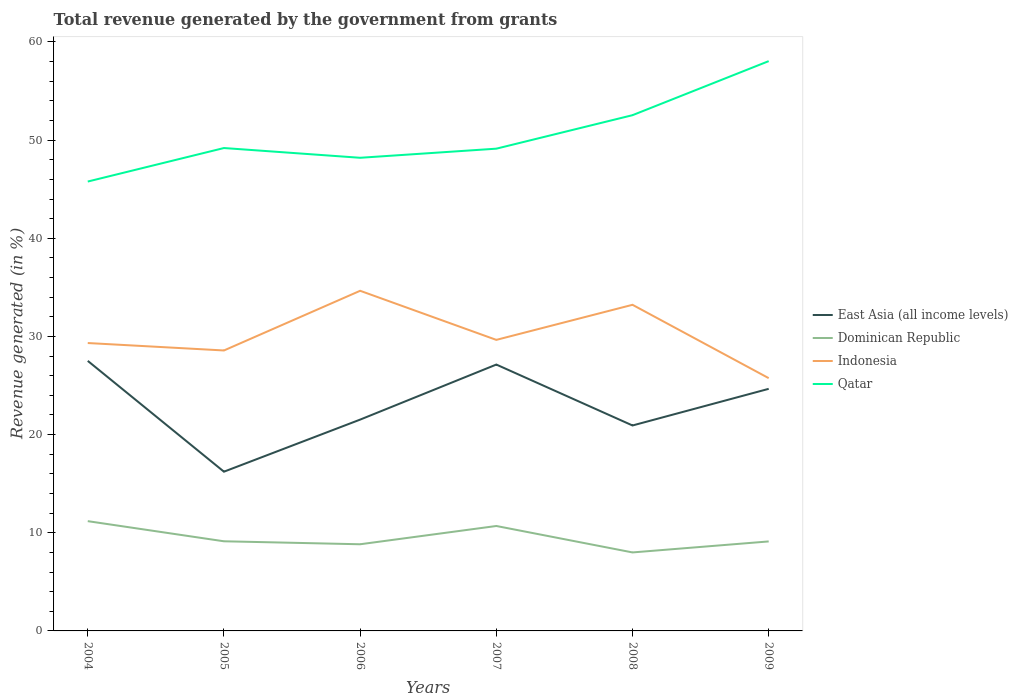How many different coloured lines are there?
Your response must be concise. 4. Does the line corresponding to Dominican Republic intersect with the line corresponding to Indonesia?
Ensure brevity in your answer.  No. Across all years, what is the maximum total revenue generated in Indonesia?
Ensure brevity in your answer.  25.75. What is the total total revenue generated in Dominican Republic in the graph?
Provide a succinct answer. 2.05. What is the difference between the highest and the second highest total revenue generated in Qatar?
Offer a very short reply. 12.27. What is the difference between two consecutive major ticks on the Y-axis?
Ensure brevity in your answer.  10. Are the values on the major ticks of Y-axis written in scientific E-notation?
Provide a succinct answer. No. Does the graph contain grids?
Your answer should be very brief. No. How many legend labels are there?
Give a very brief answer. 4. How are the legend labels stacked?
Make the answer very short. Vertical. What is the title of the graph?
Ensure brevity in your answer.  Total revenue generated by the government from grants. What is the label or title of the Y-axis?
Your answer should be very brief. Revenue generated (in %). What is the Revenue generated (in %) of East Asia (all income levels) in 2004?
Your answer should be compact. 27.51. What is the Revenue generated (in %) in Dominican Republic in 2004?
Your response must be concise. 11.18. What is the Revenue generated (in %) of Indonesia in 2004?
Offer a very short reply. 29.33. What is the Revenue generated (in %) in Qatar in 2004?
Keep it short and to the point. 45.78. What is the Revenue generated (in %) of East Asia (all income levels) in 2005?
Ensure brevity in your answer.  16.22. What is the Revenue generated (in %) in Dominican Republic in 2005?
Keep it short and to the point. 9.13. What is the Revenue generated (in %) in Indonesia in 2005?
Offer a terse response. 28.57. What is the Revenue generated (in %) in Qatar in 2005?
Give a very brief answer. 49.2. What is the Revenue generated (in %) of East Asia (all income levels) in 2006?
Your answer should be compact. 21.53. What is the Revenue generated (in %) of Dominican Republic in 2006?
Your answer should be very brief. 8.83. What is the Revenue generated (in %) of Indonesia in 2006?
Offer a very short reply. 34.65. What is the Revenue generated (in %) in Qatar in 2006?
Give a very brief answer. 48.2. What is the Revenue generated (in %) of East Asia (all income levels) in 2007?
Ensure brevity in your answer.  27.14. What is the Revenue generated (in %) in Dominican Republic in 2007?
Keep it short and to the point. 10.69. What is the Revenue generated (in %) of Indonesia in 2007?
Keep it short and to the point. 29.65. What is the Revenue generated (in %) in Qatar in 2007?
Make the answer very short. 49.13. What is the Revenue generated (in %) of East Asia (all income levels) in 2008?
Give a very brief answer. 20.93. What is the Revenue generated (in %) in Dominican Republic in 2008?
Your answer should be very brief. 8. What is the Revenue generated (in %) of Indonesia in 2008?
Offer a very short reply. 33.23. What is the Revenue generated (in %) in Qatar in 2008?
Your answer should be very brief. 52.54. What is the Revenue generated (in %) in East Asia (all income levels) in 2009?
Offer a terse response. 24.66. What is the Revenue generated (in %) in Dominican Republic in 2009?
Keep it short and to the point. 9.12. What is the Revenue generated (in %) of Indonesia in 2009?
Your answer should be very brief. 25.75. What is the Revenue generated (in %) in Qatar in 2009?
Provide a succinct answer. 58.05. Across all years, what is the maximum Revenue generated (in %) of East Asia (all income levels)?
Your answer should be very brief. 27.51. Across all years, what is the maximum Revenue generated (in %) in Dominican Republic?
Offer a terse response. 11.18. Across all years, what is the maximum Revenue generated (in %) in Indonesia?
Offer a very short reply. 34.65. Across all years, what is the maximum Revenue generated (in %) in Qatar?
Keep it short and to the point. 58.05. Across all years, what is the minimum Revenue generated (in %) in East Asia (all income levels)?
Make the answer very short. 16.22. Across all years, what is the minimum Revenue generated (in %) of Dominican Republic?
Your response must be concise. 8. Across all years, what is the minimum Revenue generated (in %) in Indonesia?
Make the answer very short. 25.75. Across all years, what is the minimum Revenue generated (in %) of Qatar?
Your response must be concise. 45.78. What is the total Revenue generated (in %) in East Asia (all income levels) in the graph?
Make the answer very short. 138. What is the total Revenue generated (in %) of Dominican Republic in the graph?
Ensure brevity in your answer.  56.95. What is the total Revenue generated (in %) of Indonesia in the graph?
Ensure brevity in your answer.  181.19. What is the total Revenue generated (in %) of Qatar in the graph?
Give a very brief answer. 302.91. What is the difference between the Revenue generated (in %) in East Asia (all income levels) in 2004 and that in 2005?
Give a very brief answer. 11.29. What is the difference between the Revenue generated (in %) of Dominican Republic in 2004 and that in 2005?
Make the answer very short. 2.05. What is the difference between the Revenue generated (in %) in Indonesia in 2004 and that in 2005?
Offer a very short reply. 0.76. What is the difference between the Revenue generated (in %) of Qatar in 2004 and that in 2005?
Ensure brevity in your answer.  -3.41. What is the difference between the Revenue generated (in %) of East Asia (all income levels) in 2004 and that in 2006?
Keep it short and to the point. 5.98. What is the difference between the Revenue generated (in %) in Dominican Republic in 2004 and that in 2006?
Make the answer very short. 2.35. What is the difference between the Revenue generated (in %) in Indonesia in 2004 and that in 2006?
Offer a terse response. -5.32. What is the difference between the Revenue generated (in %) in Qatar in 2004 and that in 2006?
Give a very brief answer. -2.42. What is the difference between the Revenue generated (in %) of East Asia (all income levels) in 2004 and that in 2007?
Ensure brevity in your answer.  0.37. What is the difference between the Revenue generated (in %) of Dominican Republic in 2004 and that in 2007?
Your answer should be very brief. 0.49. What is the difference between the Revenue generated (in %) of Indonesia in 2004 and that in 2007?
Your response must be concise. -0.32. What is the difference between the Revenue generated (in %) of Qatar in 2004 and that in 2007?
Your response must be concise. -3.35. What is the difference between the Revenue generated (in %) in East Asia (all income levels) in 2004 and that in 2008?
Your response must be concise. 6.58. What is the difference between the Revenue generated (in %) in Dominican Republic in 2004 and that in 2008?
Offer a terse response. 3.19. What is the difference between the Revenue generated (in %) of Indonesia in 2004 and that in 2008?
Your response must be concise. -3.89. What is the difference between the Revenue generated (in %) in Qatar in 2004 and that in 2008?
Ensure brevity in your answer.  -6.76. What is the difference between the Revenue generated (in %) of East Asia (all income levels) in 2004 and that in 2009?
Provide a short and direct response. 2.85. What is the difference between the Revenue generated (in %) in Dominican Republic in 2004 and that in 2009?
Your answer should be very brief. 2.07. What is the difference between the Revenue generated (in %) of Indonesia in 2004 and that in 2009?
Offer a terse response. 3.58. What is the difference between the Revenue generated (in %) of Qatar in 2004 and that in 2009?
Offer a very short reply. -12.27. What is the difference between the Revenue generated (in %) of East Asia (all income levels) in 2005 and that in 2006?
Provide a succinct answer. -5.31. What is the difference between the Revenue generated (in %) of Dominican Republic in 2005 and that in 2006?
Your answer should be compact. 0.3. What is the difference between the Revenue generated (in %) of Indonesia in 2005 and that in 2006?
Your response must be concise. -6.08. What is the difference between the Revenue generated (in %) in Qatar in 2005 and that in 2006?
Ensure brevity in your answer.  0.99. What is the difference between the Revenue generated (in %) in East Asia (all income levels) in 2005 and that in 2007?
Give a very brief answer. -10.91. What is the difference between the Revenue generated (in %) of Dominican Republic in 2005 and that in 2007?
Keep it short and to the point. -1.56. What is the difference between the Revenue generated (in %) of Indonesia in 2005 and that in 2007?
Provide a short and direct response. -1.08. What is the difference between the Revenue generated (in %) in Qatar in 2005 and that in 2007?
Your answer should be very brief. 0.06. What is the difference between the Revenue generated (in %) in East Asia (all income levels) in 2005 and that in 2008?
Provide a succinct answer. -4.71. What is the difference between the Revenue generated (in %) in Dominican Republic in 2005 and that in 2008?
Ensure brevity in your answer.  1.14. What is the difference between the Revenue generated (in %) of Indonesia in 2005 and that in 2008?
Offer a terse response. -4.65. What is the difference between the Revenue generated (in %) of Qatar in 2005 and that in 2008?
Ensure brevity in your answer.  -3.35. What is the difference between the Revenue generated (in %) of East Asia (all income levels) in 2005 and that in 2009?
Offer a very short reply. -8.44. What is the difference between the Revenue generated (in %) of Dominican Republic in 2005 and that in 2009?
Offer a very short reply. 0.01. What is the difference between the Revenue generated (in %) of Indonesia in 2005 and that in 2009?
Keep it short and to the point. 2.82. What is the difference between the Revenue generated (in %) of Qatar in 2005 and that in 2009?
Give a very brief answer. -8.85. What is the difference between the Revenue generated (in %) in East Asia (all income levels) in 2006 and that in 2007?
Provide a short and direct response. -5.61. What is the difference between the Revenue generated (in %) in Dominican Republic in 2006 and that in 2007?
Give a very brief answer. -1.86. What is the difference between the Revenue generated (in %) of Indonesia in 2006 and that in 2007?
Keep it short and to the point. 5. What is the difference between the Revenue generated (in %) of Qatar in 2006 and that in 2007?
Provide a succinct answer. -0.93. What is the difference between the Revenue generated (in %) of East Asia (all income levels) in 2006 and that in 2008?
Ensure brevity in your answer.  0.6. What is the difference between the Revenue generated (in %) in Dominican Republic in 2006 and that in 2008?
Make the answer very short. 0.83. What is the difference between the Revenue generated (in %) in Indonesia in 2006 and that in 2008?
Your answer should be compact. 1.43. What is the difference between the Revenue generated (in %) of Qatar in 2006 and that in 2008?
Offer a very short reply. -4.34. What is the difference between the Revenue generated (in %) in East Asia (all income levels) in 2006 and that in 2009?
Give a very brief answer. -3.13. What is the difference between the Revenue generated (in %) of Dominican Republic in 2006 and that in 2009?
Your answer should be very brief. -0.29. What is the difference between the Revenue generated (in %) in Indonesia in 2006 and that in 2009?
Offer a very short reply. 8.9. What is the difference between the Revenue generated (in %) in Qatar in 2006 and that in 2009?
Keep it short and to the point. -9.85. What is the difference between the Revenue generated (in %) of East Asia (all income levels) in 2007 and that in 2008?
Keep it short and to the point. 6.21. What is the difference between the Revenue generated (in %) in Dominican Republic in 2007 and that in 2008?
Provide a succinct answer. 2.69. What is the difference between the Revenue generated (in %) of Indonesia in 2007 and that in 2008?
Make the answer very short. -3.57. What is the difference between the Revenue generated (in %) of Qatar in 2007 and that in 2008?
Provide a succinct answer. -3.41. What is the difference between the Revenue generated (in %) in East Asia (all income levels) in 2007 and that in 2009?
Provide a short and direct response. 2.47. What is the difference between the Revenue generated (in %) of Dominican Republic in 2007 and that in 2009?
Offer a very short reply. 1.57. What is the difference between the Revenue generated (in %) of Indonesia in 2007 and that in 2009?
Your answer should be compact. 3.9. What is the difference between the Revenue generated (in %) in Qatar in 2007 and that in 2009?
Make the answer very short. -8.92. What is the difference between the Revenue generated (in %) of East Asia (all income levels) in 2008 and that in 2009?
Your answer should be compact. -3.73. What is the difference between the Revenue generated (in %) in Dominican Republic in 2008 and that in 2009?
Keep it short and to the point. -1.12. What is the difference between the Revenue generated (in %) of Indonesia in 2008 and that in 2009?
Your response must be concise. 7.47. What is the difference between the Revenue generated (in %) in Qatar in 2008 and that in 2009?
Your answer should be compact. -5.51. What is the difference between the Revenue generated (in %) in East Asia (all income levels) in 2004 and the Revenue generated (in %) in Dominican Republic in 2005?
Your answer should be very brief. 18.38. What is the difference between the Revenue generated (in %) of East Asia (all income levels) in 2004 and the Revenue generated (in %) of Indonesia in 2005?
Provide a short and direct response. -1.06. What is the difference between the Revenue generated (in %) in East Asia (all income levels) in 2004 and the Revenue generated (in %) in Qatar in 2005?
Give a very brief answer. -21.68. What is the difference between the Revenue generated (in %) in Dominican Republic in 2004 and the Revenue generated (in %) in Indonesia in 2005?
Keep it short and to the point. -17.39. What is the difference between the Revenue generated (in %) of Dominican Republic in 2004 and the Revenue generated (in %) of Qatar in 2005?
Provide a short and direct response. -38.01. What is the difference between the Revenue generated (in %) in Indonesia in 2004 and the Revenue generated (in %) in Qatar in 2005?
Your answer should be compact. -19.87. What is the difference between the Revenue generated (in %) of East Asia (all income levels) in 2004 and the Revenue generated (in %) of Dominican Republic in 2006?
Keep it short and to the point. 18.68. What is the difference between the Revenue generated (in %) in East Asia (all income levels) in 2004 and the Revenue generated (in %) in Indonesia in 2006?
Make the answer very short. -7.14. What is the difference between the Revenue generated (in %) of East Asia (all income levels) in 2004 and the Revenue generated (in %) of Qatar in 2006?
Make the answer very short. -20.69. What is the difference between the Revenue generated (in %) of Dominican Republic in 2004 and the Revenue generated (in %) of Indonesia in 2006?
Provide a succinct answer. -23.47. What is the difference between the Revenue generated (in %) in Dominican Republic in 2004 and the Revenue generated (in %) in Qatar in 2006?
Offer a very short reply. -37.02. What is the difference between the Revenue generated (in %) of Indonesia in 2004 and the Revenue generated (in %) of Qatar in 2006?
Offer a very short reply. -18.87. What is the difference between the Revenue generated (in %) in East Asia (all income levels) in 2004 and the Revenue generated (in %) in Dominican Republic in 2007?
Provide a short and direct response. 16.82. What is the difference between the Revenue generated (in %) of East Asia (all income levels) in 2004 and the Revenue generated (in %) of Indonesia in 2007?
Keep it short and to the point. -2.14. What is the difference between the Revenue generated (in %) of East Asia (all income levels) in 2004 and the Revenue generated (in %) of Qatar in 2007?
Make the answer very short. -21.62. What is the difference between the Revenue generated (in %) in Dominican Republic in 2004 and the Revenue generated (in %) in Indonesia in 2007?
Provide a short and direct response. -18.47. What is the difference between the Revenue generated (in %) of Dominican Republic in 2004 and the Revenue generated (in %) of Qatar in 2007?
Provide a short and direct response. -37.95. What is the difference between the Revenue generated (in %) in Indonesia in 2004 and the Revenue generated (in %) in Qatar in 2007?
Give a very brief answer. -19.8. What is the difference between the Revenue generated (in %) in East Asia (all income levels) in 2004 and the Revenue generated (in %) in Dominican Republic in 2008?
Provide a succinct answer. 19.52. What is the difference between the Revenue generated (in %) in East Asia (all income levels) in 2004 and the Revenue generated (in %) in Indonesia in 2008?
Keep it short and to the point. -5.71. What is the difference between the Revenue generated (in %) of East Asia (all income levels) in 2004 and the Revenue generated (in %) of Qatar in 2008?
Offer a very short reply. -25.03. What is the difference between the Revenue generated (in %) in Dominican Republic in 2004 and the Revenue generated (in %) in Indonesia in 2008?
Provide a short and direct response. -22.04. What is the difference between the Revenue generated (in %) in Dominican Republic in 2004 and the Revenue generated (in %) in Qatar in 2008?
Provide a succinct answer. -41.36. What is the difference between the Revenue generated (in %) of Indonesia in 2004 and the Revenue generated (in %) of Qatar in 2008?
Ensure brevity in your answer.  -23.21. What is the difference between the Revenue generated (in %) of East Asia (all income levels) in 2004 and the Revenue generated (in %) of Dominican Republic in 2009?
Make the answer very short. 18.39. What is the difference between the Revenue generated (in %) in East Asia (all income levels) in 2004 and the Revenue generated (in %) in Indonesia in 2009?
Make the answer very short. 1.76. What is the difference between the Revenue generated (in %) of East Asia (all income levels) in 2004 and the Revenue generated (in %) of Qatar in 2009?
Your response must be concise. -30.54. What is the difference between the Revenue generated (in %) in Dominican Republic in 2004 and the Revenue generated (in %) in Indonesia in 2009?
Make the answer very short. -14.57. What is the difference between the Revenue generated (in %) in Dominican Republic in 2004 and the Revenue generated (in %) in Qatar in 2009?
Offer a very short reply. -46.87. What is the difference between the Revenue generated (in %) in Indonesia in 2004 and the Revenue generated (in %) in Qatar in 2009?
Make the answer very short. -28.72. What is the difference between the Revenue generated (in %) of East Asia (all income levels) in 2005 and the Revenue generated (in %) of Dominican Republic in 2006?
Your answer should be compact. 7.39. What is the difference between the Revenue generated (in %) in East Asia (all income levels) in 2005 and the Revenue generated (in %) in Indonesia in 2006?
Your answer should be compact. -18.43. What is the difference between the Revenue generated (in %) in East Asia (all income levels) in 2005 and the Revenue generated (in %) in Qatar in 2006?
Provide a succinct answer. -31.98. What is the difference between the Revenue generated (in %) of Dominican Republic in 2005 and the Revenue generated (in %) of Indonesia in 2006?
Provide a succinct answer. -25.52. What is the difference between the Revenue generated (in %) of Dominican Republic in 2005 and the Revenue generated (in %) of Qatar in 2006?
Offer a terse response. -39.07. What is the difference between the Revenue generated (in %) in Indonesia in 2005 and the Revenue generated (in %) in Qatar in 2006?
Make the answer very short. -19.63. What is the difference between the Revenue generated (in %) in East Asia (all income levels) in 2005 and the Revenue generated (in %) in Dominican Republic in 2007?
Offer a very short reply. 5.53. What is the difference between the Revenue generated (in %) in East Asia (all income levels) in 2005 and the Revenue generated (in %) in Indonesia in 2007?
Your response must be concise. -13.43. What is the difference between the Revenue generated (in %) in East Asia (all income levels) in 2005 and the Revenue generated (in %) in Qatar in 2007?
Ensure brevity in your answer.  -32.91. What is the difference between the Revenue generated (in %) of Dominican Republic in 2005 and the Revenue generated (in %) of Indonesia in 2007?
Your answer should be very brief. -20.52. What is the difference between the Revenue generated (in %) in Dominican Republic in 2005 and the Revenue generated (in %) in Qatar in 2007?
Provide a succinct answer. -40. What is the difference between the Revenue generated (in %) of Indonesia in 2005 and the Revenue generated (in %) of Qatar in 2007?
Your response must be concise. -20.56. What is the difference between the Revenue generated (in %) of East Asia (all income levels) in 2005 and the Revenue generated (in %) of Dominican Republic in 2008?
Provide a succinct answer. 8.23. What is the difference between the Revenue generated (in %) in East Asia (all income levels) in 2005 and the Revenue generated (in %) in Indonesia in 2008?
Provide a short and direct response. -17. What is the difference between the Revenue generated (in %) in East Asia (all income levels) in 2005 and the Revenue generated (in %) in Qatar in 2008?
Keep it short and to the point. -36.32. What is the difference between the Revenue generated (in %) of Dominican Republic in 2005 and the Revenue generated (in %) of Indonesia in 2008?
Give a very brief answer. -24.09. What is the difference between the Revenue generated (in %) of Dominican Republic in 2005 and the Revenue generated (in %) of Qatar in 2008?
Your answer should be compact. -43.41. What is the difference between the Revenue generated (in %) in Indonesia in 2005 and the Revenue generated (in %) in Qatar in 2008?
Offer a terse response. -23.97. What is the difference between the Revenue generated (in %) of East Asia (all income levels) in 2005 and the Revenue generated (in %) of Dominican Republic in 2009?
Your answer should be very brief. 7.11. What is the difference between the Revenue generated (in %) of East Asia (all income levels) in 2005 and the Revenue generated (in %) of Indonesia in 2009?
Offer a terse response. -9.53. What is the difference between the Revenue generated (in %) in East Asia (all income levels) in 2005 and the Revenue generated (in %) in Qatar in 2009?
Offer a terse response. -41.83. What is the difference between the Revenue generated (in %) of Dominican Republic in 2005 and the Revenue generated (in %) of Indonesia in 2009?
Offer a very short reply. -16.62. What is the difference between the Revenue generated (in %) of Dominican Republic in 2005 and the Revenue generated (in %) of Qatar in 2009?
Your answer should be very brief. -48.92. What is the difference between the Revenue generated (in %) of Indonesia in 2005 and the Revenue generated (in %) of Qatar in 2009?
Keep it short and to the point. -29.48. What is the difference between the Revenue generated (in %) of East Asia (all income levels) in 2006 and the Revenue generated (in %) of Dominican Republic in 2007?
Provide a succinct answer. 10.84. What is the difference between the Revenue generated (in %) in East Asia (all income levels) in 2006 and the Revenue generated (in %) in Indonesia in 2007?
Keep it short and to the point. -8.12. What is the difference between the Revenue generated (in %) in East Asia (all income levels) in 2006 and the Revenue generated (in %) in Qatar in 2007?
Your answer should be very brief. -27.6. What is the difference between the Revenue generated (in %) in Dominican Republic in 2006 and the Revenue generated (in %) in Indonesia in 2007?
Offer a terse response. -20.82. What is the difference between the Revenue generated (in %) in Dominican Republic in 2006 and the Revenue generated (in %) in Qatar in 2007?
Make the answer very short. -40.3. What is the difference between the Revenue generated (in %) of Indonesia in 2006 and the Revenue generated (in %) of Qatar in 2007?
Your answer should be very brief. -14.48. What is the difference between the Revenue generated (in %) of East Asia (all income levels) in 2006 and the Revenue generated (in %) of Dominican Republic in 2008?
Your response must be concise. 13.53. What is the difference between the Revenue generated (in %) in East Asia (all income levels) in 2006 and the Revenue generated (in %) in Indonesia in 2008?
Make the answer very short. -11.7. What is the difference between the Revenue generated (in %) in East Asia (all income levels) in 2006 and the Revenue generated (in %) in Qatar in 2008?
Keep it short and to the point. -31.02. What is the difference between the Revenue generated (in %) of Dominican Republic in 2006 and the Revenue generated (in %) of Indonesia in 2008?
Make the answer very short. -24.4. What is the difference between the Revenue generated (in %) in Dominican Republic in 2006 and the Revenue generated (in %) in Qatar in 2008?
Offer a very short reply. -43.72. What is the difference between the Revenue generated (in %) in Indonesia in 2006 and the Revenue generated (in %) in Qatar in 2008?
Keep it short and to the point. -17.89. What is the difference between the Revenue generated (in %) of East Asia (all income levels) in 2006 and the Revenue generated (in %) of Dominican Republic in 2009?
Give a very brief answer. 12.41. What is the difference between the Revenue generated (in %) in East Asia (all income levels) in 2006 and the Revenue generated (in %) in Indonesia in 2009?
Make the answer very short. -4.22. What is the difference between the Revenue generated (in %) of East Asia (all income levels) in 2006 and the Revenue generated (in %) of Qatar in 2009?
Offer a very short reply. -36.52. What is the difference between the Revenue generated (in %) in Dominican Republic in 2006 and the Revenue generated (in %) in Indonesia in 2009?
Make the answer very short. -16.92. What is the difference between the Revenue generated (in %) of Dominican Republic in 2006 and the Revenue generated (in %) of Qatar in 2009?
Your answer should be compact. -49.22. What is the difference between the Revenue generated (in %) of Indonesia in 2006 and the Revenue generated (in %) of Qatar in 2009?
Offer a very short reply. -23.4. What is the difference between the Revenue generated (in %) in East Asia (all income levels) in 2007 and the Revenue generated (in %) in Dominican Republic in 2008?
Make the answer very short. 19.14. What is the difference between the Revenue generated (in %) of East Asia (all income levels) in 2007 and the Revenue generated (in %) of Indonesia in 2008?
Provide a succinct answer. -6.09. What is the difference between the Revenue generated (in %) of East Asia (all income levels) in 2007 and the Revenue generated (in %) of Qatar in 2008?
Offer a terse response. -25.41. What is the difference between the Revenue generated (in %) of Dominican Republic in 2007 and the Revenue generated (in %) of Indonesia in 2008?
Offer a terse response. -22.53. What is the difference between the Revenue generated (in %) in Dominican Republic in 2007 and the Revenue generated (in %) in Qatar in 2008?
Keep it short and to the point. -41.85. What is the difference between the Revenue generated (in %) in Indonesia in 2007 and the Revenue generated (in %) in Qatar in 2008?
Offer a very short reply. -22.89. What is the difference between the Revenue generated (in %) in East Asia (all income levels) in 2007 and the Revenue generated (in %) in Dominican Republic in 2009?
Offer a very short reply. 18.02. What is the difference between the Revenue generated (in %) in East Asia (all income levels) in 2007 and the Revenue generated (in %) in Indonesia in 2009?
Make the answer very short. 1.38. What is the difference between the Revenue generated (in %) of East Asia (all income levels) in 2007 and the Revenue generated (in %) of Qatar in 2009?
Ensure brevity in your answer.  -30.91. What is the difference between the Revenue generated (in %) in Dominican Republic in 2007 and the Revenue generated (in %) in Indonesia in 2009?
Your answer should be very brief. -15.06. What is the difference between the Revenue generated (in %) in Dominican Republic in 2007 and the Revenue generated (in %) in Qatar in 2009?
Your response must be concise. -47.36. What is the difference between the Revenue generated (in %) of Indonesia in 2007 and the Revenue generated (in %) of Qatar in 2009?
Keep it short and to the point. -28.4. What is the difference between the Revenue generated (in %) in East Asia (all income levels) in 2008 and the Revenue generated (in %) in Dominican Republic in 2009?
Ensure brevity in your answer.  11.81. What is the difference between the Revenue generated (in %) of East Asia (all income levels) in 2008 and the Revenue generated (in %) of Indonesia in 2009?
Make the answer very short. -4.82. What is the difference between the Revenue generated (in %) of East Asia (all income levels) in 2008 and the Revenue generated (in %) of Qatar in 2009?
Offer a terse response. -37.12. What is the difference between the Revenue generated (in %) of Dominican Republic in 2008 and the Revenue generated (in %) of Indonesia in 2009?
Provide a short and direct response. -17.76. What is the difference between the Revenue generated (in %) in Dominican Republic in 2008 and the Revenue generated (in %) in Qatar in 2009?
Your answer should be very brief. -50.05. What is the difference between the Revenue generated (in %) in Indonesia in 2008 and the Revenue generated (in %) in Qatar in 2009?
Make the answer very short. -24.82. What is the average Revenue generated (in %) in East Asia (all income levels) per year?
Your answer should be very brief. 23. What is the average Revenue generated (in %) in Dominican Republic per year?
Give a very brief answer. 9.49. What is the average Revenue generated (in %) of Indonesia per year?
Your response must be concise. 30.2. What is the average Revenue generated (in %) of Qatar per year?
Give a very brief answer. 50.49. In the year 2004, what is the difference between the Revenue generated (in %) in East Asia (all income levels) and Revenue generated (in %) in Dominican Republic?
Offer a very short reply. 16.33. In the year 2004, what is the difference between the Revenue generated (in %) of East Asia (all income levels) and Revenue generated (in %) of Indonesia?
Provide a succinct answer. -1.82. In the year 2004, what is the difference between the Revenue generated (in %) of East Asia (all income levels) and Revenue generated (in %) of Qatar?
Offer a terse response. -18.27. In the year 2004, what is the difference between the Revenue generated (in %) in Dominican Republic and Revenue generated (in %) in Indonesia?
Make the answer very short. -18.15. In the year 2004, what is the difference between the Revenue generated (in %) in Dominican Republic and Revenue generated (in %) in Qatar?
Your answer should be compact. -34.6. In the year 2004, what is the difference between the Revenue generated (in %) in Indonesia and Revenue generated (in %) in Qatar?
Provide a short and direct response. -16.45. In the year 2005, what is the difference between the Revenue generated (in %) of East Asia (all income levels) and Revenue generated (in %) of Dominican Republic?
Offer a terse response. 7.09. In the year 2005, what is the difference between the Revenue generated (in %) of East Asia (all income levels) and Revenue generated (in %) of Indonesia?
Ensure brevity in your answer.  -12.35. In the year 2005, what is the difference between the Revenue generated (in %) of East Asia (all income levels) and Revenue generated (in %) of Qatar?
Keep it short and to the point. -32.97. In the year 2005, what is the difference between the Revenue generated (in %) of Dominican Republic and Revenue generated (in %) of Indonesia?
Keep it short and to the point. -19.44. In the year 2005, what is the difference between the Revenue generated (in %) in Dominican Republic and Revenue generated (in %) in Qatar?
Offer a very short reply. -40.06. In the year 2005, what is the difference between the Revenue generated (in %) in Indonesia and Revenue generated (in %) in Qatar?
Your answer should be very brief. -20.62. In the year 2006, what is the difference between the Revenue generated (in %) of East Asia (all income levels) and Revenue generated (in %) of Dominican Republic?
Offer a very short reply. 12.7. In the year 2006, what is the difference between the Revenue generated (in %) of East Asia (all income levels) and Revenue generated (in %) of Indonesia?
Offer a very short reply. -13.12. In the year 2006, what is the difference between the Revenue generated (in %) of East Asia (all income levels) and Revenue generated (in %) of Qatar?
Offer a very short reply. -26.68. In the year 2006, what is the difference between the Revenue generated (in %) in Dominican Republic and Revenue generated (in %) in Indonesia?
Provide a succinct answer. -25.82. In the year 2006, what is the difference between the Revenue generated (in %) of Dominican Republic and Revenue generated (in %) of Qatar?
Give a very brief answer. -39.38. In the year 2006, what is the difference between the Revenue generated (in %) of Indonesia and Revenue generated (in %) of Qatar?
Provide a short and direct response. -13.55. In the year 2007, what is the difference between the Revenue generated (in %) in East Asia (all income levels) and Revenue generated (in %) in Dominican Republic?
Offer a very short reply. 16.45. In the year 2007, what is the difference between the Revenue generated (in %) in East Asia (all income levels) and Revenue generated (in %) in Indonesia?
Provide a succinct answer. -2.51. In the year 2007, what is the difference between the Revenue generated (in %) in East Asia (all income levels) and Revenue generated (in %) in Qatar?
Provide a short and direct response. -21.99. In the year 2007, what is the difference between the Revenue generated (in %) of Dominican Republic and Revenue generated (in %) of Indonesia?
Provide a succinct answer. -18.96. In the year 2007, what is the difference between the Revenue generated (in %) in Dominican Republic and Revenue generated (in %) in Qatar?
Your response must be concise. -38.44. In the year 2007, what is the difference between the Revenue generated (in %) in Indonesia and Revenue generated (in %) in Qatar?
Make the answer very short. -19.48. In the year 2008, what is the difference between the Revenue generated (in %) of East Asia (all income levels) and Revenue generated (in %) of Dominican Republic?
Ensure brevity in your answer.  12.93. In the year 2008, what is the difference between the Revenue generated (in %) in East Asia (all income levels) and Revenue generated (in %) in Indonesia?
Keep it short and to the point. -12.29. In the year 2008, what is the difference between the Revenue generated (in %) in East Asia (all income levels) and Revenue generated (in %) in Qatar?
Provide a short and direct response. -31.61. In the year 2008, what is the difference between the Revenue generated (in %) in Dominican Republic and Revenue generated (in %) in Indonesia?
Give a very brief answer. -25.23. In the year 2008, what is the difference between the Revenue generated (in %) of Dominican Republic and Revenue generated (in %) of Qatar?
Ensure brevity in your answer.  -44.55. In the year 2008, what is the difference between the Revenue generated (in %) in Indonesia and Revenue generated (in %) in Qatar?
Offer a terse response. -19.32. In the year 2009, what is the difference between the Revenue generated (in %) in East Asia (all income levels) and Revenue generated (in %) in Dominican Republic?
Offer a very short reply. 15.55. In the year 2009, what is the difference between the Revenue generated (in %) in East Asia (all income levels) and Revenue generated (in %) in Indonesia?
Your answer should be very brief. -1.09. In the year 2009, what is the difference between the Revenue generated (in %) in East Asia (all income levels) and Revenue generated (in %) in Qatar?
Provide a short and direct response. -33.39. In the year 2009, what is the difference between the Revenue generated (in %) of Dominican Republic and Revenue generated (in %) of Indonesia?
Your answer should be very brief. -16.64. In the year 2009, what is the difference between the Revenue generated (in %) of Dominican Republic and Revenue generated (in %) of Qatar?
Keep it short and to the point. -48.93. In the year 2009, what is the difference between the Revenue generated (in %) in Indonesia and Revenue generated (in %) in Qatar?
Ensure brevity in your answer.  -32.3. What is the ratio of the Revenue generated (in %) in East Asia (all income levels) in 2004 to that in 2005?
Give a very brief answer. 1.7. What is the ratio of the Revenue generated (in %) in Dominican Republic in 2004 to that in 2005?
Give a very brief answer. 1.22. What is the ratio of the Revenue generated (in %) of Indonesia in 2004 to that in 2005?
Make the answer very short. 1.03. What is the ratio of the Revenue generated (in %) in Qatar in 2004 to that in 2005?
Your answer should be compact. 0.93. What is the ratio of the Revenue generated (in %) of East Asia (all income levels) in 2004 to that in 2006?
Your answer should be very brief. 1.28. What is the ratio of the Revenue generated (in %) of Dominican Republic in 2004 to that in 2006?
Your answer should be very brief. 1.27. What is the ratio of the Revenue generated (in %) of Indonesia in 2004 to that in 2006?
Your response must be concise. 0.85. What is the ratio of the Revenue generated (in %) of Qatar in 2004 to that in 2006?
Your answer should be very brief. 0.95. What is the ratio of the Revenue generated (in %) in East Asia (all income levels) in 2004 to that in 2007?
Your answer should be compact. 1.01. What is the ratio of the Revenue generated (in %) in Dominican Republic in 2004 to that in 2007?
Give a very brief answer. 1.05. What is the ratio of the Revenue generated (in %) of Indonesia in 2004 to that in 2007?
Provide a succinct answer. 0.99. What is the ratio of the Revenue generated (in %) of Qatar in 2004 to that in 2007?
Provide a succinct answer. 0.93. What is the ratio of the Revenue generated (in %) of East Asia (all income levels) in 2004 to that in 2008?
Ensure brevity in your answer.  1.31. What is the ratio of the Revenue generated (in %) of Dominican Republic in 2004 to that in 2008?
Ensure brevity in your answer.  1.4. What is the ratio of the Revenue generated (in %) of Indonesia in 2004 to that in 2008?
Ensure brevity in your answer.  0.88. What is the ratio of the Revenue generated (in %) in Qatar in 2004 to that in 2008?
Give a very brief answer. 0.87. What is the ratio of the Revenue generated (in %) in East Asia (all income levels) in 2004 to that in 2009?
Offer a terse response. 1.12. What is the ratio of the Revenue generated (in %) in Dominican Republic in 2004 to that in 2009?
Your response must be concise. 1.23. What is the ratio of the Revenue generated (in %) in Indonesia in 2004 to that in 2009?
Your response must be concise. 1.14. What is the ratio of the Revenue generated (in %) of Qatar in 2004 to that in 2009?
Provide a short and direct response. 0.79. What is the ratio of the Revenue generated (in %) in East Asia (all income levels) in 2005 to that in 2006?
Make the answer very short. 0.75. What is the ratio of the Revenue generated (in %) in Dominican Republic in 2005 to that in 2006?
Give a very brief answer. 1.03. What is the ratio of the Revenue generated (in %) of Indonesia in 2005 to that in 2006?
Give a very brief answer. 0.82. What is the ratio of the Revenue generated (in %) in Qatar in 2005 to that in 2006?
Give a very brief answer. 1.02. What is the ratio of the Revenue generated (in %) of East Asia (all income levels) in 2005 to that in 2007?
Provide a short and direct response. 0.6. What is the ratio of the Revenue generated (in %) of Dominican Republic in 2005 to that in 2007?
Offer a terse response. 0.85. What is the ratio of the Revenue generated (in %) of Indonesia in 2005 to that in 2007?
Provide a succinct answer. 0.96. What is the ratio of the Revenue generated (in %) in East Asia (all income levels) in 2005 to that in 2008?
Provide a short and direct response. 0.78. What is the ratio of the Revenue generated (in %) of Dominican Republic in 2005 to that in 2008?
Offer a terse response. 1.14. What is the ratio of the Revenue generated (in %) in Indonesia in 2005 to that in 2008?
Your answer should be very brief. 0.86. What is the ratio of the Revenue generated (in %) of Qatar in 2005 to that in 2008?
Give a very brief answer. 0.94. What is the ratio of the Revenue generated (in %) in East Asia (all income levels) in 2005 to that in 2009?
Make the answer very short. 0.66. What is the ratio of the Revenue generated (in %) of Dominican Republic in 2005 to that in 2009?
Offer a terse response. 1. What is the ratio of the Revenue generated (in %) in Indonesia in 2005 to that in 2009?
Offer a terse response. 1.11. What is the ratio of the Revenue generated (in %) of Qatar in 2005 to that in 2009?
Your answer should be compact. 0.85. What is the ratio of the Revenue generated (in %) of East Asia (all income levels) in 2006 to that in 2007?
Provide a short and direct response. 0.79. What is the ratio of the Revenue generated (in %) in Dominican Republic in 2006 to that in 2007?
Offer a terse response. 0.83. What is the ratio of the Revenue generated (in %) of Indonesia in 2006 to that in 2007?
Offer a very short reply. 1.17. What is the ratio of the Revenue generated (in %) in Qatar in 2006 to that in 2007?
Provide a succinct answer. 0.98. What is the ratio of the Revenue generated (in %) in East Asia (all income levels) in 2006 to that in 2008?
Provide a succinct answer. 1.03. What is the ratio of the Revenue generated (in %) in Dominican Republic in 2006 to that in 2008?
Give a very brief answer. 1.1. What is the ratio of the Revenue generated (in %) of Indonesia in 2006 to that in 2008?
Give a very brief answer. 1.04. What is the ratio of the Revenue generated (in %) in Qatar in 2006 to that in 2008?
Give a very brief answer. 0.92. What is the ratio of the Revenue generated (in %) of East Asia (all income levels) in 2006 to that in 2009?
Your response must be concise. 0.87. What is the ratio of the Revenue generated (in %) in Dominican Republic in 2006 to that in 2009?
Your answer should be compact. 0.97. What is the ratio of the Revenue generated (in %) in Indonesia in 2006 to that in 2009?
Your answer should be very brief. 1.35. What is the ratio of the Revenue generated (in %) in Qatar in 2006 to that in 2009?
Provide a succinct answer. 0.83. What is the ratio of the Revenue generated (in %) of East Asia (all income levels) in 2007 to that in 2008?
Offer a very short reply. 1.3. What is the ratio of the Revenue generated (in %) in Dominican Republic in 2007 to that in 2008?
Give a very brief answer. 1.34. What is the ratio of the Revenue generated (in %) of Indonesia in 2007 to that in 2008?
Provide a succinct answer. 0.89. What is the ratio of the Revenue generated (in %) of Qatar in 2007 to that in 2008?
Your answer should be very brief. 0.94. What is the ratio of the Revenue generated (in %) of East Asia (all income levels) in 2007 to that in 2009?
Provide a short and direct response. 1.1. What is the ratio of the Revenue generated (in %) of Dominican Republic in 2007 to that in 2009?
Provide a succinct answer. 1.17. What is the ratio of the Revenue generated (in %) of Indonesia in 2007 to that in 2009?
Your response must be concise. 1.15. What is the ratio of the Revenue generated (in %) in Qatar in 2007 to that in 2009?
Your answer should be very brief. 0.85. What is the ratio of the Revenue generated (in %) in East Asia (all income levels) in 2008 to that in 2009?
Your response must be concise. 0.85. What is the ratio of the Revenue generated (in %) of Dominican Republic in 2008 to that in 2009?
Make the answer very short. 0.88. What is the ratio of the Revenue generated (in %) in Indonesia in 2008 to that in 2009?
Keep it short and to the point. 1.29. What is the ratio of the Revenue generated (in %) of Qatar in 2008 to that in 2009?
Make the answer very short. 0.91. What is the difference between the highest and the second highest Revenue generated (in %) in East Asia (all income levels)?
Give a very brief answer. 0.37. What is the difference between the highest and the second highest Revenue generated (in %) in Dominican Republic?
Offer a terse response. 0.49. What is the difference between the highest and the second highest Revenue generated (in %) of Indonesia?
Provide a succinct answer. 1.43. What is the difference between the highest and the second highest Revenue generated (in %) of Qatar?
Your answer should be compact. 5.51. What is the difference between the highest and the lowest Revenue generated (in %) in East Asia (all income levels)?
Provide a short and direct response. 11.29. What is the difference between the highest and the lowest Revenue generated (in %) in Dominican Republic?
Offer a very short reply. 3.19. What is the difference between the highest and the lowest Revenue generated (in %) in Indonesia?
Provide a succinct answer. 8.9. What is the difference between the highest and the lowest Revenue generated (in %) in Qatar?
Your answer should be very brief. 12.27. 